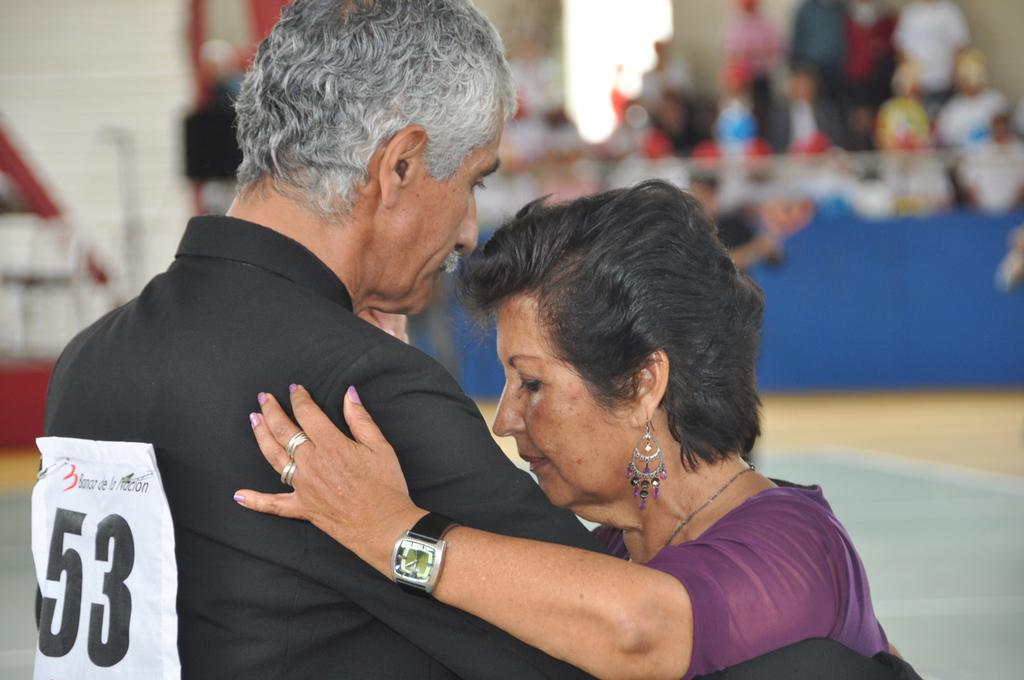<image>
Share a concise interpretation of the image provided. A woman and man wearing number 53 on his back dancing. 